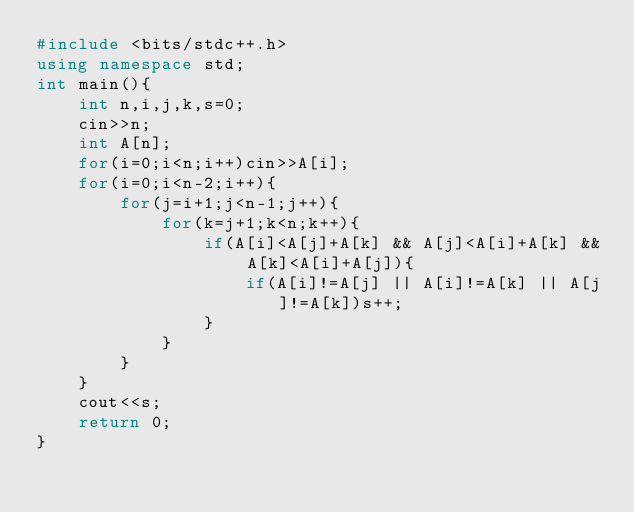<code> <loc_0><loc_0><loc_500><loc_500><_C++_>#include <bits/stdc++.h>
using namespace std;
int main(){
	int n,i,j,k,s=0;
	cin>>n;
	int A[n];
	for(i=0;i<n;i++)cin>>A[i];
	for(i=0;i<n-2;i++){
		for(j=i+1;j<n-1;j++){
			for(k=j+1;k<n;k++){
				if(A[i]<A[j]+A[k] && A[j]<A[i]+A[k] && A[k]<A[i]+A[j]){
					if(A[i]!=A[j] || A[i]!=A[k] || A[j]!=A[k])s++;
				}
			}
		}
	}
	cout<<s;
	return 0;
}</code> 